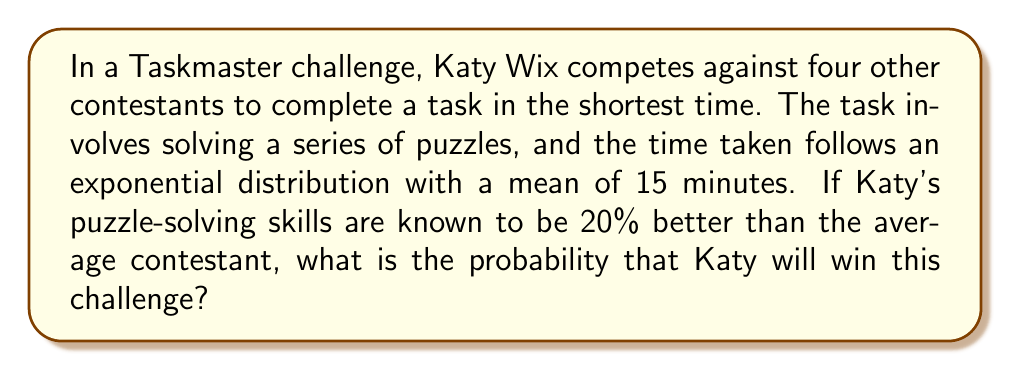Help me with this question. Let's approach this step-by-step:

1) The time taken for an average contestant follows an exponential distribution with mean 15 minutes. The probability density function (PDF) of an exponential distribution is:

   $$f(t) = \lambda e^{-\lambda t}$$

   where $\lambda$ is the rate parameter, which is the inverse of the mean. So, $\lambda = \frac{1}{15}$.

2) Katy's skills are 20% better than average, so her mean time would be 80% of 15 minutes, which is 12 minutes. Her rate parameter is $\lambda_K = \frac{1}{12}$.

3) For Katy to win, her time must be less than all other contestants. The probability of this happening is:

   $$P(\text{Katy wins}) = \int_0^\infty P(\text{Katy's time} = t) \cdot P(\text{All others > t})^4 dt$$

4) The probability that Katy's time is exactly $t$ is given by her PDF: $f_K(t) = \frac{1}{12}e^{-t/12}$

5) The probability that another contestant's time is greater than $t$ is given by the survival function:

   $$S(t) = 1 - F(t) = e^{-t/15}$$

6) Putting this all together:

   $$P(\text{Katy wins}) = \int_0^\infty \frac{1}{12}e^{-t/12} \cdot (e^{-t/15})^4 dt$$

7) Simplifying:

   $$P(\text{Katy wins}) = \frac{1}{12} \int_0^\infty e^{-t/12 - 4t/15} dt = \frac{1}{12} \int_0^\infty e^{-11t/60} dt$$

8) Solving this integral:

   $$P(\text{Katy wins}) = \frac{1}{12} \cdot \frac{60}{11} = \frac{5}{11} \approx 0.4545$$
Answer: The probability that Katy Wix will win this Taskmaster challenge is $\frac{5}{11}$ or approximately 0.4545 (45.45%). 